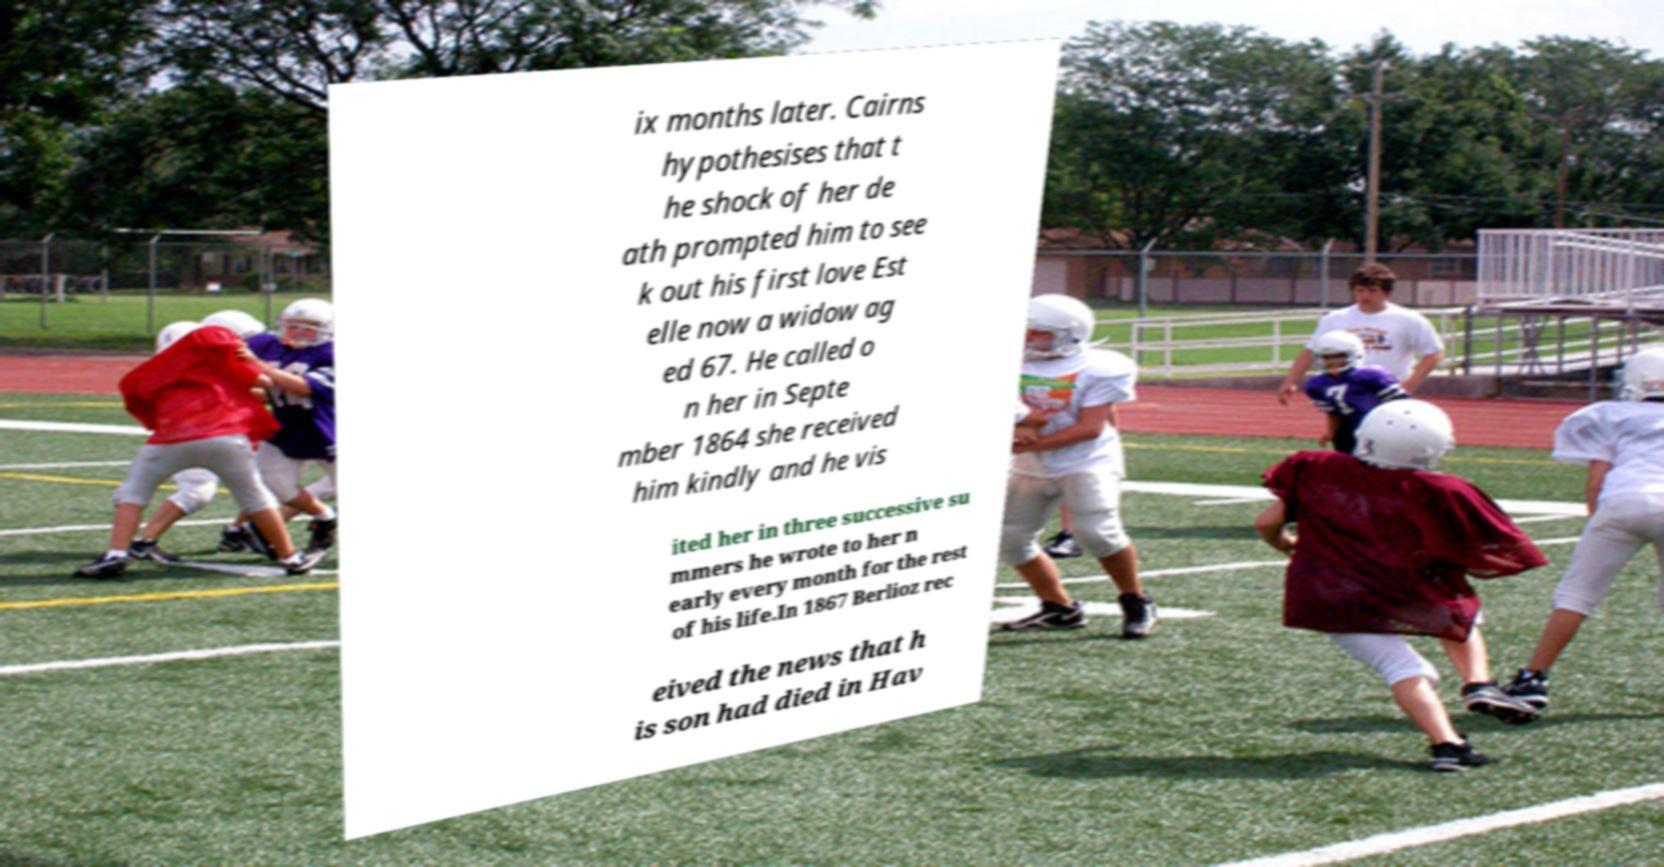Could you extract and type out the text from this image? ix months later. Cairns hypothesises that t he shock of her de ath prompted him to see k out his first love Est elle now a widow ag ed 67. He called o n her in Septe mber 1864 she received him kindly and he vis ited her in three successive su mmers he wrote to her n early every month for the rest of his life.In 1867 Berlioz rec eived the news that h is son had died in Hav 